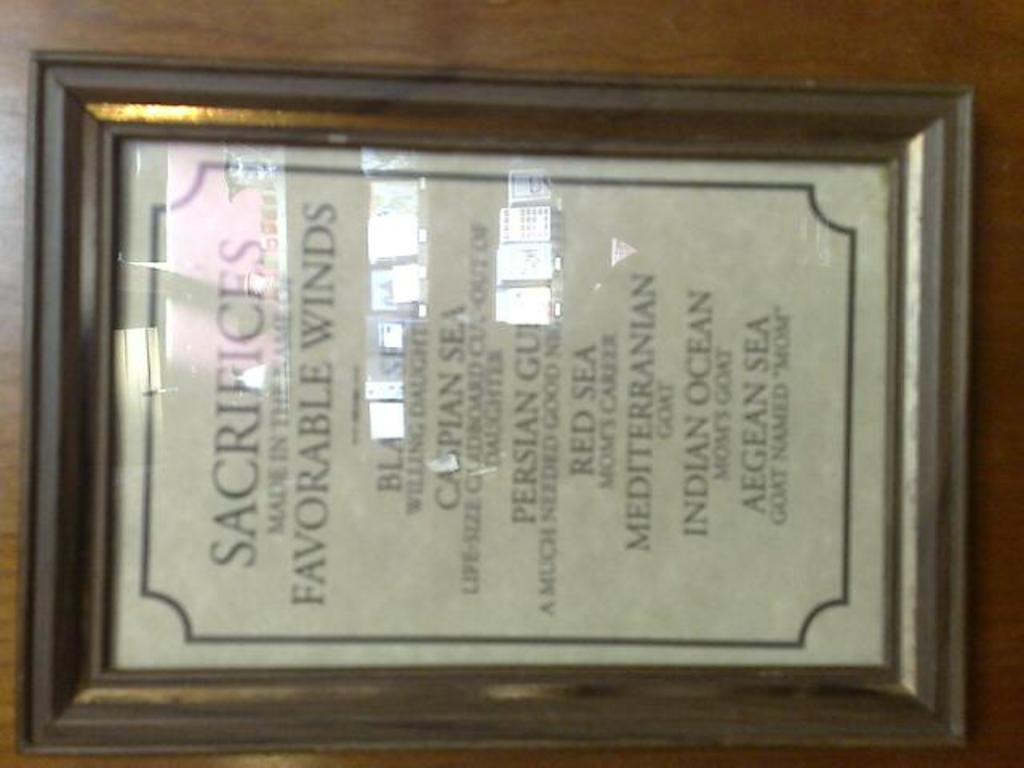<image>
Give a short and clear explanation of the subsequent image. A horizontal display of sacrifice made in the name of favorable winds. 